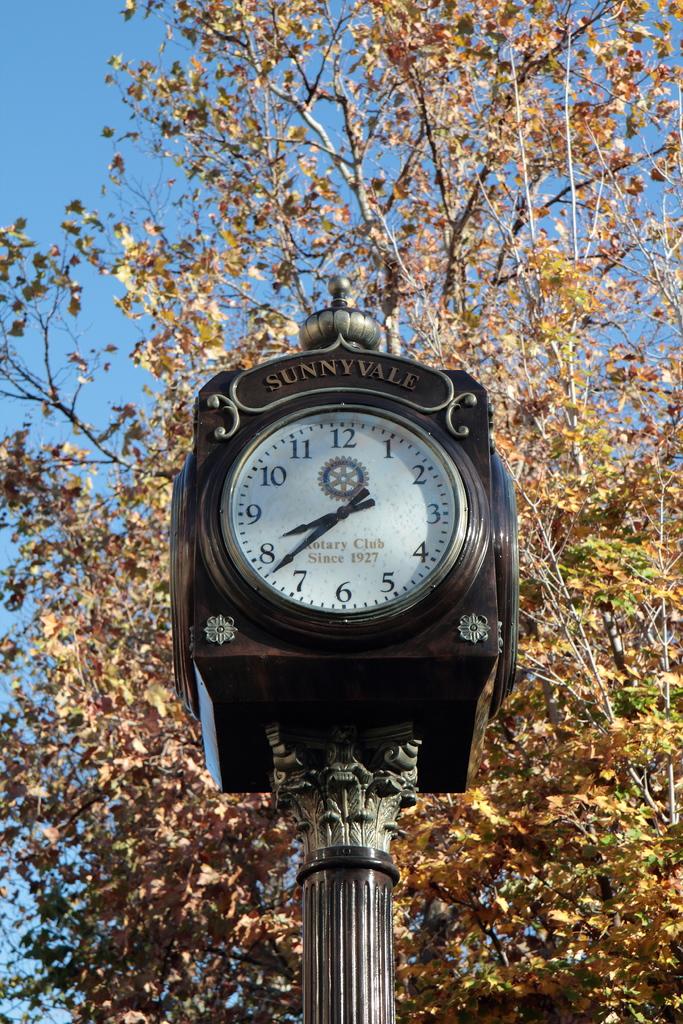What is the name on the top of this clock?
Provide a short and direct response. Sunnyvale. What number is a little hand closest to?
Your answer should be compact. 8. 